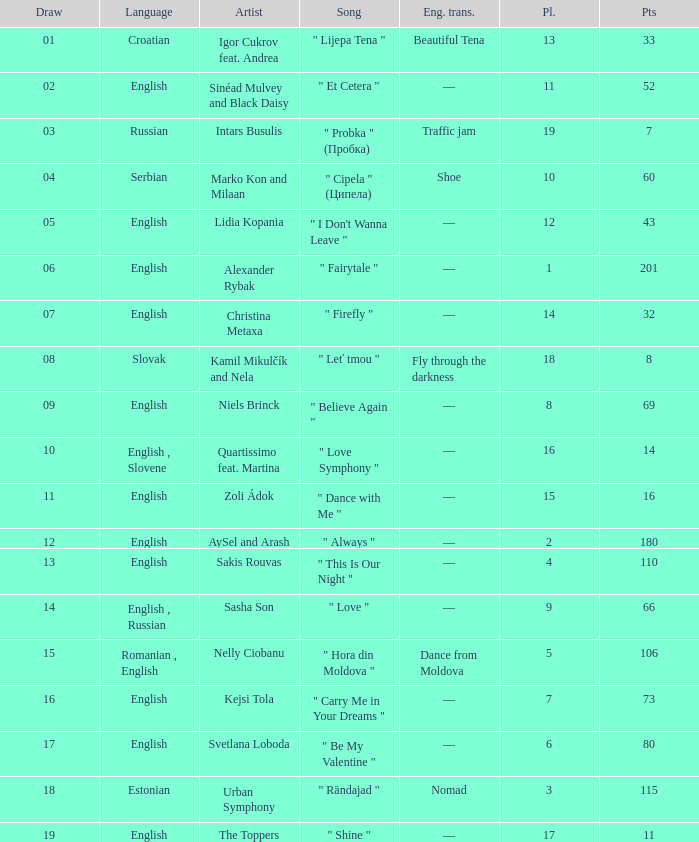What is the english translation when the language is english, draw is smaller than 16, and the artist is aysel and arash? —. 